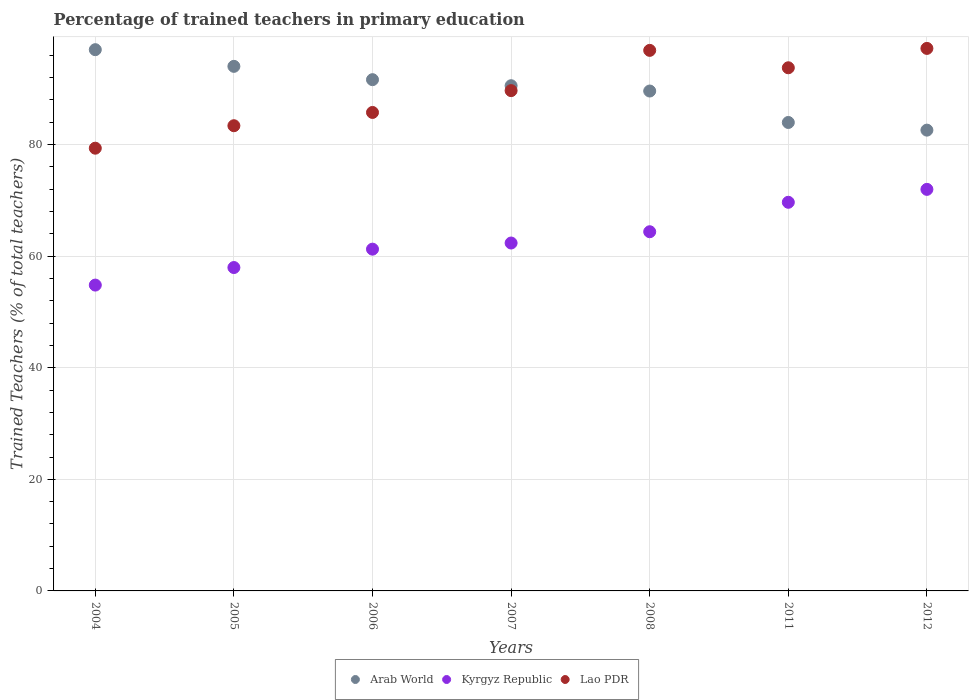Is the number of dotlines equal to the number of legend labels?
Your response must be concise. Yes. What is the percentage of trained teachers in Lao PDR in 2008?
Your answer should be compact. 96.89. Across all years, what is the maximum percentage of trained teachers in Arab World?
Your response must be concise. 97.01. Across all years, what is the minimum percentage of trained teachers in Kyrgyz Republic?
Your answer should be very brief. 54.82. In which year was the percentage of trained teachers in Arab World maximum?
Offer a very short reply. 2004. In which year was the percentage of trained teachers in Lao PDR minimum?
Offer a terse response. 2004. What is the total percentage of trained teachers in Arab World in the graph?
Your answer should be very brief. 629.37. What is the difference between the percentage of trained teachers in Arab World in 2004 and that in 2006?
Provide a short and direct response. 5.38. What is the difference between the percentage of trained teachers in Arab World in 2004 and the percentage of trained teachers in Kyrgyz Republic in 2008?
Ensure brevity in your answer.  32.63. What is the average percentage of trained teachers in Arab World per year?
Your answer should be compact. 89.91. In the year 2007, what is the difference between the percentage of trained teachers in Arab World and percentage of trained teachers in Lao PDR?
Offer a very short reply. 0.88. In how many years, is the percentage of trained teachers in Arab World greater than 8 %?
Keep it short and to the point. 7. What is the ratio of the percentage of trained teachers in Kyrgyz Republic in 2011 to that in 2012?
Make the answer very short. 0.97. Is the percentage of trained teachers in Arab World in 2007 less than that in 2011?
Offer a terse response. No. Is the difference between the percentage of trained teachers in Arab World in 2007 and 2012 greater than the difference between the percentage of trained teachers in Lao PDR in 2007 and 2012?
Your answer should be compact. Yes. What is the difference between the highest and the second highest percentage of trained teachers in Lao PDR?
Make the answer very short. 0.35. What is the difference between the highest and the lowest percentage of trained teachers in Kyrgyz Republic?
Ensure brevity in your answer.  17.16. Is the sum of the percentage of trained teachers in Arab World in 2004 and 2008 greater than the maximum percentage of trained teachers in Lao PDR across all years?
Give a very brief answer. Yes. Is it the case that in every year, the sum of the percentage of trained teachers in Arab World and percentage of trained teachers in Kyrgyz Republic  is greater than the percentage of trained teachers in Lao PDR?
Your answer should be compact. Yes. Does the percentage of trained teachers in Lao PDR monotonically increase over the years?
Your answer should be very brief. No. Is the percentage of trained teachers in Arab World strictly less than the percentage of trained teachers in Lao PDR over the years?
Ensure brevity in your answer.  No. How many dotlines are there?
Your answer should be compact. 3. How many years are there in the graph?
Ensure brevity in your answer.  7. Are the values on the major ticks of Y-axis written in scientific E-notation?
Give a very brief answer. No. What is the title of the graph?
Your response must be concise. Percentage of trained teachers in primary education. What is the label or title of the Y-axis?
Ensure brevity in your answer.  Trained Teachers (% of total teachers). What is the Trained Teachers (% of total teachers) in Arab World in 2004?
Ensure brevity in your answer.  97.01. What is the Trained Teachers (% of total teachers) of Kyrgyz Republic in 2004?
Your answer should be very brief. 54.82. What is the Trained Teachers (% of total teachers) of Lao PDR in 2004?
Your answer should be compact. 79.35. What is the Trained Teachers (% of total teachers) of Arab World in 2005?
Give a very brief answer. 94.02. What is the Trained Teachers (% of total teachers) in Kyrgyz Republic in 2005?
Your answer should be compact. 57.96. What is the Trained Teachers (% of total teachers) of Lao PDR in 2005?
Give a very brief answer. 83.38. What is the Trained Teachers (% of total teachers) of Arab World in 2006?
Ensure brevity in your answer.  91.63. What is the Trained Teachers (% of total teachers) in Kyrgyz Republic in 2006?
Offer a very short reply. 61.26. What is the Trained Teachers (% of total teachers) in Lao PDR in 2006?
Offer a very short reply. 85.76. What is the Trained Teachers (% of total teachers) in Arab World in 2007?
Give a very brief answer. 90.55. What is the Trained Teachers (% of total teachers) of Kyrgyz Republic in 2007?
Make the answer very short. 62.36. What is the Trained Teachers (% of total teachers) of Lao PDR in 2007?
Offer a terse response. 89.67. What is the Trained Teachers (% of total teachers) in Arab World in 2008?
Make the answer very short. 89.6. What is the Trained Teachers (% of total teachers) in Kyrgyz Republic in 2008?
Provide a succinct answer. 64.38. What is the Trained Teachers (% of total teachers) in Lao PDR in 2008?
Give a very brief answer. 96.89. What is the Trained Teachers (% of total teachers) in Arab World in 2011?
Offer a terse response. 83.96. What is the Trained Teachers (% of total teachers) in Kyrgyz Republic in 2011?
Ensure brevity in your answer.  69.66. What is the Trained Teachers (% of total teachers) of Lao PDR in 2011?
Ensure brevity in your answer.  93.77. What is the Trained Teachers (% of total teachers) of Arab World in 2012?
Your answer should be very brief. 82.59. What is the Trained Teachers (% of total teachers) of Kyrgyz Republic in 2012?
Offer a very short reply. 71.97. What is the Trained Teachers (% of total teachers) in Lao PDR in 2012?
Your response must be concise. 97.24. Across all years, what is the maximum Trained Teachers (% of total teachers) in Arab World?
Make the answer very short. 97.01. Across all years, what is the maximum Trained Teachers (% of total teachers) of Kyrgyz Republic?
Ensure brevity in your answer.  71.97. Across all years, what is the maximum Trained Teachers (% of total teachers) of Lao PDR?
Ensure brevity in your answer.  97.24. Across all years, what is the minimum Trained Teachers (% of total teachers) of Arab World?
Your answer should be compact. 82.59. Across all years, what is the minimum Trained Teachers (% of total teachers) of Kyrgyz Republic?
Offer a very short reply. 54.82. Across all years, what is the minimum Trained Teachers (% of total teachers) of Lao PDR?
Keep it short and to the point. 79.35. What is the total Trained Teachers (% of total teachers) in Arab World in the graph?
Provide a short and direct response. 629.37. What is the total Trained Teachers (% of total teachers) in Kyrgyz Republic in the graph?
Provide a short and direct response. 442.4. What is the total Trained Teachers (% of total teachers) of Lao PDR in the graph?
Offer a very short reply. 626.05. What is the difference between the Trained Teachers (% of total teachers) in Arab World in 2004 and that in 2005?
Give a very brief answer. 2.99. What is the difference between the Trained Teachers (% of total teachers) of Kyrgyz Republic in 2004 and that in 2005?
Your answer should be compact. -3.14. What is the difference between the Trained Teachers (% of total teachers) in Lao PDR in 2004 and that in 2005?
Give a very brief answer. -4.03. What is the difference between the Trained Teachers (% of total teachers) of Arab World in 2004 and that in 2006?
Provide a short and direct response. 5.38. What is the difference between the Trained Teachers (% of total teachers) in Kyrgyz Republic in 2004 and that in 2006?
Offer a very short reply. -6.44. What is the difference between the Trained Teachers (% of total teachers) of Lao PDR in 2004 and that in 2006?
Ensure brevity in your answer.  -6.41. What is the difference between the Trained Teachers (% of total teachers) in Arab World in 2004 and that in 2007?
Your response must be concise. 6.46. What is the difference between the Trained Teachers (% of total teachers) in Kyrgyz Republic in 2004 and that in 2007?
Provide a succinct answer. -7.54. What is the difference between the Trained Teachers (% of total teachers) of Lao PDR in 2004 and that in 2007?
Your answer should be compact. -10.32. What is the difference between the Trained Teachers (% of total teachers) of Arab World in 2004 and that in 2008?
Your response must be concise. 7.41. What is the difference between the Trained Teachers (% of total teachers) of Kyrgyz Republic in 2004 and that in 2008?
Provide a short and direct response. -9.56. What is the difference between the Trained Teachers (% of total teachers) of Lao PDR in 2004 and that in 2008?
Your answer should be compact. -17.53. What is the difference between the Trained Teachers (% of total teachers) of Arab World in 2004 and that in 2011?
Offer a very short reply. 13.05. What is the difference between the Trained Teachers (% of total teachers) in Kyrgyz Republic in 2004 and that in 2011?
Keep it short and to the point. -14.84. What is the difference between the Trained Teachers (% of total teachers) of Lao PDR in 2004 and that in 2011?
Make the answer very short. -14.41. What is the difference between the Trained Teachers (% of total teachers) in Arab World in 2004 and that in 2012?
Offer a terse response. 14.42. What is the difference between the Trained Teachers (% of total teachers) in Kyrgyz Republic in 2004 and that in 2012?
Keep it short and to the point. -17.16. What is the difference between the Trained Teachers (% of total teachers) of Lao PDR in 2004 and that in 2012?
Make the answer very short. -17.88. What is the difference between the Trained Teachers (% of total teachers) of Arab World in 2005 and that in 2006?
Ensure brevity in your answer.  2.39. What is the difference between the Trained Teachers (% of total teachers) in Kyrgyz Republic in 2005 and that in 2006?
Ensure brevity in your answer.  -3.29. What is the difference between the Trained Teachers (% of total teachers) in Lao PDR in 2005 and that in 2006?
Give a very brief answer. -2.38. What is the difference between the Trained Teachers (% of total teachers) of Arab World in 2005 and that in 2007?
Offer a very short reply. 3.47. What is the difference between the Trained Teachers (% of total teachers) of Kyrgyz Republic in 2005 and that in 2007?
Offer a very short reply. -4.4. What is the difference between the Trained Teachers (% of total teachers) of Lao PDR in 2005 and that in 2007?
Offer a very short reply. -6.29. What is the difference between the Trained Teachers (% of total teachers) in Arab World in 2005 and that in 2008?
Your answer should be compact. 4.42. What is the difference between the Trained Teachers (% of total teachers) of Kyrgyz Republic in 2005 and that in 2008?
Make the answer very short. -6.42. What is the difference between the Trained Teachers (% of total teachers) in Lao PDR in 2005 and that in 2008?
Your answer should be compact. -13.5. What is the difference between the Trained Teachers (% of total teachers) of Arab World in 2005 and that in 2011?
Keep it short and to the point. 10.06. What is the difference between the Trained Teachers (% of total teachers) of Kyrgyz Republic in 2005 and that in 2011?
Give a very brief answer. -11.7. What is the difference between the Trained Teachers (% of total teachers) in Lao PDR in 2005 and that in 2011?
Make the answer very short. -10.39. What is the difference between the Trained Teachers (% of total teachers) of Arab World in 2005 and that in 2012?
Your answer should be compact. 11.43. What is the difference between the Trained Teachers (% of total teachers) of Kyrgyz Republic in 2005 and that in 2012?
Give a very brief answer. -14.01. What is the difference between the Trained Teachers (% of total teachers) of Lao PDR in 2005 and that in 2012?
Offer a very short reply. -13.86. What is the difference between the Trained Teachers (% of total teachers) in Arab World in 2006 and that in 2007?
Provide a succinct answer. 1.08. What is the difference between the Trained Teachers (% of total teachers) of Kyrgyz Republic in 2006 and that in 2007?
Your response must be concise. -1.1. What is the difference between the Trained Teachers (% of total teachers) in Lao PDR in 2006 and that in 2007?
Your response must be concise. -3.91. What is the difference between the Trained Teachers (% of total teachers) of Arab World in 2006 and that in 2008?
Offer a very short reply. 2.04. What is the difference between the Trained Teachers (% of total teachers) in Kyrgyz Republic in 2006 and that in 2008?
Your answer should be very brief. -3.12. What is the difference between the Trained Teachers (% of total teachers) in Lao PDR in 2006 and that in 2008?
Your answer should be very brief. -11.13. What is the difference between the Trained Teachers (% of total teachers) of Arab World in 2006 and that in 2011?
Provide a succinct answer. 7.67. What is the difference between the Trained Teachers (% of total teachers) of Kyrgyz Republic in 2006 and that in 2011?
Keep it short and to the point. -8.4. What is the difference between the Trained Teachers (% of total teachers) in Lao PDR in 2006 and that in 2011?
Your response must be concise. -8.01. What is the difference between the Trained Teachers (% of total teachers) in Arab World in 2006 and that in 2012?
Make the answer very short. 9.05. What is the difference between the Trained Teachers (% of total teachers) in Kyrgyz Republic in 2006 and that in 2012?
Your answer should be very brief. -10.72. What is the difference between the Trained Teachers (% of total teachers) of Lao PDR in 2006 and that in 2012?
Make the answer very short. -11.48. What is the difference between the Trained Teachers (% of total teachers) of Kyrgyz Republic in 2007 and that in 2008?
Your answer should be compact. -2.02. What is the difference between the Trained Teachers (% of total teachers) of Lao PDR in 2007 and that in 2008?
Keep it short and to the point. -7.22. What is the difference between the Trained Teachers (% of total teachers) in Arab World in 2007 and that in 2011?
Provide a short and direct response. 6.59. What is the difference between the Trained Teachers (% of total teachers) of Kyrgyz Republic in 2007 and that in 2011?
Your answer should be compact. -7.3. What is the difference between the Trained Teachers (% of total teachers) in Lao PDR in 2007 and that in 2011?
Keep it short and to the point. -4.1. What is the difference between the Trained Teachers (% of total teachers) in Arab World in 2007 and that in 2012?
Give a very brief answer. 7.96. What is the difference between the Trained Teachers (% of total teachers) of Kyrgyz Republic in 2007 and that in 2012?
Offer a very short reply. -9.62. What is the difference between the Trained Teachers (% of total teachers) of Lao PDR in 2007 and that in 2012?
Keep it short and to the point. -7.57. What is the difference between the Trained Teachers (% of total teachers) of Arab World in 2008 and that in 2011?
Your response must be concise. 5.64. What is the difference between the Trained Teachers (% of total teachers) in Kyrgyz Republic in 2008 and that in 2011?
Ensure brevity in your answer.  -5.28. What is the difference between the Trained Teachers (% of total teachers) of Lao PDR in 2008 and that in 2011?
Provide a succinct answer. 3.12. What is the difference between the Trained Teachers (% of total teachers) in Arab World in 2008 and that in 2012?
Provide a short and direct response. 7.01. What is the difference between the Trained Teachers (% of total teachers) of Kyrgyz Republic in 2008 and that in 2012?
Your response must be concise. -7.59. What is the difference between the Trained Teachers (% of total teachers) of Lao PDR in 2008 and that in 2012?
Make the answer very short. -0.35. What is the difference between the Trained Teachers (% of total teachers) in Arab World in 2011 and that in 2012?
Ensure brevity in your answer.  1.37. What is the difference between the Trained Teachers (% of total teachers) in Kyrgyz Republic in 2011 and that in 2012?
Your answer should be very brief. -2.32. What is the difference between the Trained Teachers (% of total teachers) of Lao PDR in 2011 and that in 2012?
Your answer should be very brief. -3.47. What is the difference between the Trained Teachers (% of total teachers) in Arab World in 2004 and the Trained Teachers (% of total teachers) in Kyrgyz Republic in 2005?
Your response must be concise. 39.05. What is the difference between the Trained Teachers (% of total teachers) of Arab World in 2004 and the Trained Teachers (% of total teachers) of Lao PDR in 2005?
Provide a succinct answer. 13.63. What is the difference between the Trained Teachers (% of total teachers) in Kyrgyz Republic in 2004 and the Trained Teachers (% of total teachers) in Lao PDR in 2005?
Offer a very short reply. -28.56. What is the difference between the Trained Teachers (% of total teachers) of Arab World in 2004 and the Trained Teachers (% of total teachers) of Kyrgyz Republic in 2006?
Your answer should be very brief. 35.75. What is the difference between the Trained Teachers (% of total teachers) in Arab World in 2004 and the Trained Teachers (% of total teachers) in Lao PDR in 2006?
Offer a terse response. 11.25. What is the difference between the Trained Teachers (% of total teachers) of Kyrgyz Republic in 2004 and the Trained Teachers (% of total teachers) of Lao PDR in 2006?
Your response must be concise. -30.94. What is the difference between the Trained Teachers (% of total teachers) of Arab World in 2004 and the Trained Teachers (% of total teachers) of Kyrgyz Republic in 2007?
Keep it short and to the point. 34.65. What is the difference between the Trained Teachers (% of total teachers) of Arab World in 2004 and the Trained Teachers (% of total teachers) of Lao PDR in 2007?
Your response must be concise. 7.34. What is the difference between the Trained Teachers (% of total teachers) of Kyrgyz Republic in 2004 and the Trained Teachers (% of total teachers) of Lao PDR in 2007?
Your response must be concise. -34.85. What is the difference between the Trained Teachers (% of total teachers) in Arab World in 2004 and the Trained Teachers (% of total teachers) in Kyrgyz Republic in 2008?
Your answer should be very brief. 32.63. What is the difference between the Trained Teachers (% of total teachers) in Arab World in 2004 and the Trained Teachers (% of total teachers) in Lao PDR in 2008?
Make the answer very short. 0.12. What is the difference between the Trained Teachers (% of total teachers) of Kyrgyz Republic in 2004 and the Trained Teachers (% of total teachers) of Lao PDR in 2008?
Give a very brief answer. -42.07. What is the difference between the Trained Teachers (% of total teachers) of Arab World in 2004 and the Trained Teachers (% of total teachers) of Kyrgyz Republic in 2011?
Your answer should be very brief. 27.35. What is the difference between the Trained Teachers (% of total teachers) in Arab World in 2004 and the Trained Teachers (% of total teachers) in Lao PDR in 2011?
Provide a succinct answer. 3.24. What is the difference between the Trained Teachers (% of total teachers) of Kyrgyz Republic in 2004 and the Trained Teachers (% of total teachers) of Lao PDR in 2011?
Make the answer very short. -38.95. What is the difference between the Trained Teachers (% of total teachers) in Arab World in 2004 and the Trained Teachers (% of total teachers) in Kyrgyz Republic in 2012?
Provide a succinct answer. 25.04. What is the difference between the Trained Teachers (% of total teachers) in Arab World in 2004 and the Trained Teachers (% of total teachers) in Lao PDR in 2012?
Give a very brief answer. -0.23. What is the difference between the Trained Teachers (% of total teachers) in Kyrgyz Republic in 2004 and the Trained Teachers (% of total teachers) in Lao PDR in 2012?
Provide a short and direct response. -42.42. What is the difference between the Trained Teachers (% of total teachers) of Arab World in 2005 and the Trained Teachers (% of total teachers) of Kyrgyz Republic in 2006?
Your answer should be compact. 32.77. What is the difference between the Trained Teachers (% of total teachers) of Arab World in 2005 and the Trained Teachers (% of total teachers) of Lao PDR in 2006?
Make the answer very short. 8.26. What is the difference between the Trained Teachers (% of total teachers) of Kyrgyz Republic in 2005 and the Trained Teachers (% of total teachers) of Lao PDR in 2006?
Give a very brief answer. -27.8. What is the difference between the Trained Teachers (% of total teachers) in Arab World in 2005 and the Trained Teachers (% of total teachers) in Kyrgyz Republic in 2007?
Give a very brief answer. 31.66. What is the difference between the Trained Teachers (% of total teachers) of Arab World in 2005 and the Trained Teachers (% of total teachers) of Lao PDR in 2007?
Offer a very short reply. 4.35. What is the difference between the Trained Teachers (% of total teachers) in Kyrgyz Republic in 2005 and the Trained Teachers (% of total teachers) in Lao PDR in 2007?
Keep it short and to the point. -31.71. What is the difference between the Trained Teachers (% of total teachers) of Arab World in 2005 and the Trained Teachers (% of total teachers) of Kyrgyz Republic in 2008?
Offer a terse response. 29.64. What is the difference between the Trained Teachers (% of total teachers) of Arab World in 2005 and the Trained Teachers (% of total teachers) of Lao PDR in 2008?
Your response must be concise. -2.86. What is the difference between the Trained Teachers (% of total teachers) in Kyrgyz Republic in 2005 and the Trained Teachers (% of total teachers) in Lao PDR in 2008?
Your answer should be compact. -38.92. What is the difference between the Trained Teachers (% of total teachers) in Arab World in 2005 and the Trained Teachers (% of total teachers) in Kyrgyz Republic in 2011?
Offer a very short reply. 24.36. What is the difference between the Trained Teachers (% of total teachers) of Arab World in 2005 and the Trained Teachers (% of total teachers) of Lao PDR in 2011?
Provide a succinct answer. 0.26. What is the difference between the Trained Teachers (% of total teachers) of Kyrgyz Republic in 2005 and the Trained Teachers (% of total teachers) of Lao PDR in 2011?
Your answer should be compact. -35.8. What is the difference between the Trained Teachers (% of total teachers) in Arab World in 2005 and the Trained Teachers (% of total teachers) in Kyrgyz Republic in 2012?
Your response must be concise. 22.05. What is the difference between the Trained Teachers (% of total teachers) in Arab World in 2005 and the Trained Teachers (% of total teachers) in Lao PDR in 2012?
Your answer should be compact. -3.22. What is the difference between the Trained Teachers (% of total teachers) of Kyrgyz Republic in 2005 and the Trained Teachers (% of total teachers) of Lao PDR in 2012?
Offer a very short reply. -39.28. What is the difference between the Trained Teachers (% of total teachers) in Arab World in 2006 and the Trained Teachers (% of total teachers) in Kyrgyz Republic in 2007?
Your answer should be very brief. 29.28. What is the difference between the Trained Teachers (% of total teachers) of Arab World in 2006 and the Trained Teachers (% of total teachers) of Lao PDR in 2007?
Ensure brevity in your answer.  1.96. What is the difference between the Trained Teachers (% of total teachers) in Kyrgyz Republic in 2006 and the Trained Teachers (% of total teachers) in Lao PDR in 2007?
Provide a short and direct response. -28.41. What is the difference between the Trained Teachers (% of total teachers) of Arab World in 2006 and the Trained Teachers (% of total teachers) of Kyrgyz Republic in 2008?
Offer a terse response. 27.26. What is the difference between the Trained Teachers (% of total teachers) of Arab World in 2006 and the Trained Teachers (% of total teachers) of Lao PDR in 2008?
Provide a short and direct response. -5.25. What is the difference between the Trained Teachers (% of total teachers) in Kyrgyz Republic in 2006 and the Trained Teachers (% of total teachers) in Lao PDR in 2008?
Offer a very short reply. -35.63. What is the difference between the Trained Teachers (% of total teachers) in Arab World in 2006 and the Trained Teachers (% of total teachers) in Kyrgyz Republic in 2011?
Your response must be concise. 21.98. What is the difference between the Trained Teachers (% of total teachers) of Arab World in 2006 and the Trained Teachers (% of total teachers) of Lao PDR in 2011?
Give a very brief answer. -2.13. What is the difference between the Trained Teachers (% of total teachers) of Kyrgyz Republic in 2006 and the Trained Teachers (% of total teachers) of Lao PDR in 2011?
Give a very brief answer. -32.51. What is the difference between the Trained Teachers (% of total teachers) of Arab World in 2006 and the Trained Teachers (% of total teachers) of Kyrgyz Republic in 2012?
Provide a short and direct response. 19.66. What is the difference between the Trained Teachers (% of total teachers) of Arab World in 2006 and the Trained Teachers (% of total teachers) of Lao PDR in 2012?
Keep it short and to the point. -5.6. What is the difference between the Trained Teachers (% of total teachers) of Kyrgyz Republic in 2006 and the Trained Teachers (% of total teachers) of Lao PDR in 2012?
Offer a terse response. -35.98. What is the difference between the Trained Teachers (% of total teachers) of Arab World in 2007 and the Trained Teachers (% of total teachers) of Kyrgyz Republic in 2008?
Your answer should be very brief. 26.17. What is the difference between the Trained Teachers (% of total teachers) of Arab World in 2007 and the Trained Teachers (% of total teachers) of Lao PDR in 2008?
Offer a terse response. -6.33. What is the difference between the Trained Teachers (% of total teachers) in Kyrgyz Republic in 2007 and the Trained Teachers (% of total teachers) in Lao PDR in 2008?
Give a very brief answer. -34.53. What is the difference between the Trained Teachers (% of total teachers) of Arab World in 2007 and the Trained Teachers (% of total teachers) of Kyrgyz Republic in 2011?
Give a very brief answer. 20.89. What is the difference between the Trained Teachers (% of total teachers) of Arab World in 2007 and the Trained Teachers (% of total teachers) of Lao PDR in 2011?
Your response must be concise. -3.22. What is the difference between the Trained Teachers (% of total teachers) in Kyrgyz Republic in 2007 and the Trained Teachers (% of total teachers) in Lao PDR in 2011?
Give a very brief answer. -31.41. What is the difference between the Trained Teachers (% of total teachers) of Arab World in 2007 and the Trained Teachers (% of total teachers) of Kyrgyz Republic in 2012?
Your answer should be very brief. 18.58. What is the difference between the Trained Teachers (% of total teachers) in Arab World in 2007 and the Trained Teachers (% of total teachers) in Lao PDR in 2012?
Make the answer very short. -6.69. What is the difference between the Trained Teachers (% of total teachers) of Kyrgyz Republic in 2007 and the Trained Teachers (% of total teachers) of Lao PDR in 2012?
Ensure brevity in your answer.  -34.88. What is the difference between the Trained Teachers (% of total teachers) in Arab World in 2008 and the Trained Teachers (% of total teachers) in Kyrgyz Republic in 2011?
Give a very brief answer. 19.94. What is the difference between the Trained Teachers (% of total teachers) of Arab World in 2008 and the Trained Teachers (% of total teachers) of Lao PDR in 2011?
Offer a very short reply. -4.17. What is the difference between the Trained Teachers (% of total teachers) of Kyrgyz Republic in 2008 and the Trained Teachers (% of total teachers) of Lao PDR in 2011?
Your response must be concise. -29.39. What is the difference between the Trained Teachers (% of total teachers) in Arab World in 2008 and the Trained Teachers (% of total teachers) in Kyrgyz Republic in 2012?
Offer a terse response. 17.63. What is the difference between the Trained Teachers (% of total teachers) in Arab World in 2008 and the Trained Teachers (% of total teachers) in Lao PDR in 2012?
Keep it short and to the point. -7.64. What is the difference between the Trained Teachers (% of total teachers) of Kyrgyz Republic in 2008 and the Trained Teachers (% of total teachers) of Lao PDR in 2012?
Make the answer very short. -32.86. What is the difference between the Trained Teachers (% of total teachers) in Arab World in 2011 and the Trained Teachers (% of total teachers) in Kyrgyz Republic in 2012?
Make the answer very short. 11.99. What is the difference between the Trained Teachers (% of total teachers) of Arab World in 2011 and the Trained Teachers (% of total teachers) of Lao PDR in 2012?
Provide a short and direct response. -13.27. What is the difference between the Trained Teachers (% of total teachers) of Kyrgyz Republic in 2011 and the Trained Teachers (% of total teachers) of Lao PDR in 2012?
Your answer should be very brief. -27.58. What is the average Trained Teachers (% of total teachers) in Arab World per year?
Make the answer very short. 89.91. What is the average Trained Teachers (% of total teachers) in Kyrgyz Republic per year?
Provide a succinct answer. 63.2. What is the average Trained Teachers (% of total teachers) of Lao PDR per year?
Offer a terse response. 89.44. In the year 2004, what is the difference between the Trained Teachers (% of total teachers) of Arab World and Trained Teachers (% of total teachers) of Kyrgyz Republic?
Provide a succinct answer. 42.19. In the year 2004, what is the difference between the Trained Teachers (% of total teachers) in Arab World and Trained Teachers (% of total teachers) in Lao PDR?
Make the answer very short. 17.66. In the year 2004, what is the difference between the Trained Teachers (% of total teachers) of Kyrgyz Republic and Trained Teachers (% of total teachers) of Lao PDR?
Your answer should be compact. -24.54. In the year 2005, what is the difference between the Trained Teachers (% of total teachers) of Arab World and Trained Teachers (% of total teachers) of Kyrgyz Republic?
Give a very brief answer. 36.06. In the year 2005, what is the difference between the Trained Teachers (% of total teachers) in Arab World and Trained Teachers (% of total teachers) in Lao PDR?
Your answer should be compact. 10.64. In the year 2005, what is the difference between the Trained Teachers (% of total teachers) in Kyrgyz Republic and Trained Teachers (% of total teachers) in Lao PDR?
Offer a terse response. -25.42. In the year 2006, what is the difference between the Trained Teachers (% of total teachers) in Arab World and Trained Teachers (% of total teachers) in Kyrgyz Republic?
Your answer should be compact. 30.38. In the year 2006, what is the difference between the Trained Teachers (% of total teachers) of Arab World and Trained Teachers (% of total teachers) of Lao PDR?
Ensure brevity in your answer.  5.88. In the year 2006, what is the difference between the Trained Teachers (% of total teachers) in Kyrgyz Republic and Trained Teachers (% of total teachers) in Lao PDR?
Your response must be concise. -24.5. In the year 2007, what is the difference between the Trained Teachers (% of total teachers) in Arab World and Trained Teachers (% of total teachers) in Kyrgyz Republic?
Ensure brevity in your answer.  28.19. In the year 2007, what is the difference between the Trained Teachers (% of total teachers) in Arab World and Trained Teachers (% of total teachers) in Lao PDR?
Keep it short and to the point. 0.88. In the year 2007, what is the difference between the Trained Teachers (% of total teachers) in Kyrgyz Republic and Trained Teachers (% of total teachers) in Lao PDR?
Your response must be concise. -27.31. In the year 2008, what is the difference between the Trained Teachers (% of total teachers) of Arab World and Trained Teachers (% of total teachers) of Kyrgyz Republic?
Provide a short and direct response. 25.22. In the year 2008, what is the difference between the Trained Teachers (% of total teachers) of Arab World and Trained Teachers (% of total teachers) of Lao PDR?
Keep it short and to the point. -7.29. In the year 2008, what is the difference between the Trained Teachers (% of total teachers) in Kyrgyz Republic and Trained Teachers (% of total teachers) in Lao PDR?
Offer a very short reply. -32.51. In the year 2011, what is the difference between the Trained Teachers (% of total teachers) of Arab World and Trained Teachers (% of total teachers) of Kyrgyz Republic?
Ensure brevity in your answer.  14.31. In the year 2011, what is the difference between the Trained Teachers (% of total teachers) in Arab World and Trained Teachers (% of total teachers) in Lao PDR?
Your answer should be very brief. -9.8. In the year 2011, what is the difference between the Trained Teachers (% of total teachers) of Kyrgyz Republic and Trained Teachers (% of total teachers) of Lao PDR?
Offer a very short reply. -24.11. In the year 2012, what is the difference between the Trained Teachers (% of total teachers) of Arab World and Trained Teachers (% of total teachers) of Kyrgyz Republic?
Your answer should be compact. 10.62. In the year 2012, what is the difference between the Trained Teachers (% of total teachers) in Arab World and Trained Teachers (% of total teachers) in Lao PDR?
Give a very brief answer. -14.65. In the year 2012, what is the difference between the Trained Teachers (% of total teachers) in Kyrgyz Republic and Trained Teachers (% of total teachers) in Lao PDR?
Provide a short and direct response. -25.26. What is the ratio of the Trained Teachers (% of total teachers) of Arab World in 2004 to that in 2005?
Your answer should be very brief. 1.03. What is the ratio of the Trained Teachers (% of total teachers) of Kyrgyz Republic in 2004 to that in 2005?
Keep it short and to the point. 0.95. What is the ratio of the Trained Teachers (% of total teachers) in Lao PDR in 2004 to that in 2005?
Your response must be concise. 0.95. What is the ratio of the Trained Teachers (% of total teachers) in Arab World in 2004 to that in 2006?
Give a very brief answer. 1.06. What is the ratio of the Trained Teachers (% of total teachers) of Kyrgyz Republic in 2004 to that in 2006?
Offer a very short reply. 0.89. What is the ratio of the Trained Teachers (% of total teachers) in Lao PDR in 2004 to that in 2006?
Ensure brevity in your answer.  0.93. What is the ratio of the Trained Teachers (% of total teachers) in Arab World in 2004 to that in 2007?
Your answer should be very brief. 1.07. What is the ratio of the Trained Teachers (% of total teachers) in Kyrgyz Republic in 2004 to that in 2007?
Offer a terse response. 0.88. What is the ratio of the Trained Teachers (% of total teachers) in Lao PDR in 2004 to that in 2007?
Give a very brief answer. 0.88. What is the ratio of the Trained Teachers (% of total teachers) of Arab World in 2004 to that in 2008?
Ensure brevity in your answer.  1.08. What is the ratio of the Trained Teachers (% of total teachers) of Kyrgyz Republic in 2004 to that in 2008?
Your response must be concise. 0.85. What is the ratio of the Trained Teachers (% of total teachers) of Lao PDR in 2004 to that in 2008?
Make the answer very short. 0.82. What is the ratio of the Trained Teachers (% of total teachers) in Arab World in 2004 to that in 2011?
Provide a short and direct response. 1.16. What is the ratio of the Trained Teachers (% of total teachers) of Kyrgyz Republic in 2004 to that in 2011?
Provide a short and direct response. 0.79. What is the ratio of the Trained Teachers (% of total teachers) in Lao PDR in 2004 to that in 2011?
Your answer should be compact. 0.85. What is the ratio of the Trained Teachers (% of total teachers) in Arab World in 2004 to that in 2012?
Your answer should be compact. 1.17. What is the ratio of the Trained Teachers (% of total teachers) in Kyrgyz Republic in 2004 to that in 2012?
Offer a terse response. 0.76. What is the ratio of the Trained Teachers (% of total teachers) of Lao PDR in 2004 to that in 2012?
Provide a short and direct response. 0.82. What is the ratio of the Trained Teachers (% of total teachers) in Arab World in 2005 to that in 2006?
Offer a terse response. 1.03. What is the ratio of the Trained Teachers (% of total teachers) in Kyrgyz Republic in 2005 to that in 2006?
Make the answer very short. 0.95. What is the ratio of the Trained Teachers (% of total teachers) in Lao PDR in 2005 to that in 2006?
Your answer should be compact. 0.97. What is the ratio of the Trained Teachers (% of total teachers) of Arab World in 2005 to that in 2007?
Make the answer very short. 1.04. What is the ratio of the Trained Teachers (% of total teachers) of Kyrgyz Republic in 2005 to that in 2007?
Offer a terse response. 0.93. What is the ratio of the Trained Teachers (% of total teachers) in Lao PDR in 2005 to that in 2007?
Make the answer very short. 0.93. What is the ratio of the Trained Teachers (% of total teachers) of Arab World in 2005 to that in 2008?
Keep it short and to the point. 1.05. What is the ratio of the Trained Teachers (% of total teachers) of Kyrgyz Republic in 2005 to that in 2008?
Make the answer very short. 0.9. What is the ratio of the Trained Teachers (% of total teachers) in Lao PDR in 2005 to that in 2008?
Ensure brevity in your answer.  0.86. What is the ratio of the Trained Teachers (% of total teachers) of Arab World in 2005 to that in 2011?
Offer a terse response. 1.12. What is the ratio of the Trained Teachers (% of total teachers) of Kyrgyz Republic in 2005 to that in 2011?
Make the answer very short. 0.83. What is the ratio of the Trained Teachers (% of total teachers) of Lao PDR in 2005 to that in 2011?
Keep it short and to the point. 0.89. What is the ratio of the Trained Teachers (% of total teachers) in Arab World in 2005 to that in 2012?
Your response must be concise. 1.14. What is the ratio of the Trained Teachers (% of total teachers) of Kyrgyz Republic in 2005 to that in 2012?
Offer a terse response. 0.81. What is the ratio of the Trained Teachers (% of total teachers) of Lao PDR in 2005 to that in 2012?
Offer a terse response. 0.86. What is the ratio of the Trained Teachers (% of total teachers) of Kyrgyz Republic in 2006 to that in 2007?
Offer a terse response. 0.98. What is the ratio of the Trained Teachers (% of total teachers) of Lao PDR in 2006 to that in 2007?
Make the answer very short. 0.96. What is the ratio of the Trained Teachers (% of total teachers) in Arab World in 2006 to that in 2008?
Offer a terse response. 1.02. What is the ratio of the Trained Teachers (% of total teachers) in Kyrgyz Republic in 2006 to that in 2008?
Your answer should be very brief. 0.95. What is the ratio of the Trained Teachers (% of total teachers) in Lao PDR in 2006 to that in 2008?
Offer a very short reply. 0.89. What is the ratio of the Trained Teachers (% of total teachers) in Arab World in 2006 to that in 2011?
Ensure brevity in your answer.  1.09. What is the ratio of the Trained Teachers (% of total teachers) of Kyrgyz Republic in 2006 to that in 2011?
Offer a terse response. 0.88. What is the ratio of the Trained Teachers (% of total teachers) in Lao PDR in 2006 to that in 2011?
Your answer should be compact. 0.91. What is the ratio of the Trained Teachers (% of total teachers) in Arab World in 2006 to that in 2012?
Keep it short and to the point. 1.11. What is the ratio of the Trained Teachers (% of total teachers) of Kyrgyz Republic in 2006 to that in 2012?
Make the answer very short. 0.85. What is the ratio of the Trained Teachers (% of total teachers) in Lao PDR in 2006 to that in 2012?
Provide a succinct answer. 0.88. What is the ratio of the Trained Teachers (% of total teachers) in Arab World in 2007 to that in 2008?
Provide a succinct answer. 1.01. What is the ratio of the Trained Teachers (% of total teachers) in Kyrgyz Republic in 2007 to that in 2008?
Your answer should be compact. 0.97. What is the ratio of the Trained Teachers (% of total teachers) of Lao PDR in 2007 to that in 2008?
Keep it short and to the point. 0.93. What is the ratio of the Trained Teachers (% of total teachers) of Arab World in 2007 to that in 2011?
Make the answer very short. 1.08. What is the ratio of the Trained Teachers (% of total teachers) of Kyrgyz Republic in 2007 to that in 2011?
Your answer should be very brief. 0.9. What is the ratio of the Trained Teachers (% of total teachers) of Lao PDR in 2007 to that in 2011?
Keep it short and to the point. 0.96. What is the ratio of the Trained Teachers (% of total teachers) in Arab World in 2007 to that in 2012?
Offer a very short reply. 1.1. What is the ratio of the Trained Teachers (% of total teachers) of Kyrgyz Republic in 2007 to that in 2012?
Give a very brief answer. 0.87. What is the ratio of the Trained Teachers (% of total teachers) of Lao PDR in 2007 to that in 2012?
Offer a very short reply. 0.92. What is the ratio of the Trained Teachers (% of total teachers) of Arab World in 2008 to that in 2011?
Provide a succinct answer. 1.07. What is the ratio of the Trained Teachers (% of total teachers) in Kyrgyz Republic in 2008 to that in 2011?
Offer a very short reply. 0.92. What is the ratio of the Trained Teachers (% of total teachers) of Arab World in 2008 to that in 2012?
Offer a terse response. 1.08. What is the ratio of the Trained Teachers (% of total teachers) of Kyrgyz Republic in 2008 to that in 2012?
Keep it short and to the point. 0.89. What is the ratio of the Trained Teachers (% of total teachers) in Arab World in 2011 to that in 2012?
Ensure brevity in your answer.  1.02. What is the ratio of the Trained Teachers (% of total teachers) of Kyrgyz Republic in 2011 to that in 2012?
Provide a succinct answer. 0.97. What is the ratio of the Trained Teachers (% of total teachers) of Lao PDR in 2011 to that in 2012?
Your answer should be compact. 0.96. What is the difference between the highest and the second highest Trained Teachers (% of total teachers) in Arab World?
Make the answer very short. 2.99. What is the difference between the highest and the second highest Trained Teachers (% of total teachers) in Kyrgyz Republic?
Offer a very short reply. 2.32. What is the difference between the highest and the second highest Trained Teachers (% of total teachers) in Lao PDR?
Offer a very short reply. 0.35. What is the difference between the highest and the lowest Trained Teachers (% of total teachers) in Arab World?
Provide a short and direct response. 14.42. What is the difference between the highest and the lowest Trained Teachers (% of total teachers) in Kyrgyz Republic?
Offer a terse response. 17.16. What is the difference between the highest and the lowest Trained Teachers (% of total teachers) in Lao PDR?
Make the answer very short. 17.88. 